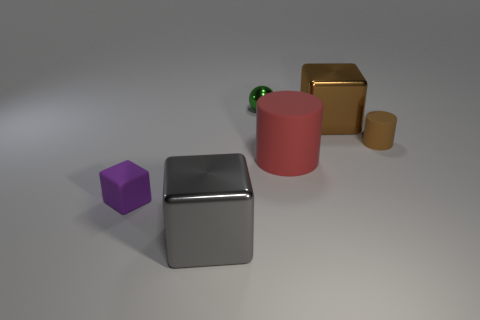There is a tiny object that is right of the big brown block; is its shape the same as the red object right of the gray metal block?
Make the answer very short. Yes. Is the number of large brown cubes in front of the big brown thing greater than the number of big brown metallic things behind the small metal ball?
Your answer should be compact. No. How many objects are things left of the gray thing or tiny brown metallic cylinders?
Ensure brevity in your answer.  1. The small thing that is the same material as the small brown cylinder is what shape?
Give a very brief answer. Cube. Is there any other thing that has the same shape as the green object?
Provide a short and direct response. No. The tiny object that is in front of the small ball and to the left of the brown cylinder is what color?
Offer a very short reply. Purple. How many spheres are big brown metal things or tiny brown things?
Provide a succinct answer. 0. How many cylinders have the same size as the brown matte object?
Your answer should be compact. 0. There is a object to the left of the gray shiny thing; what number of tiny green metal spheres are left of it?
Offer a terse response. 0. How big is the metal object that is in front of the tiny green shiny ball and behind the gray metal thing?
Offer a terse response. Large. 